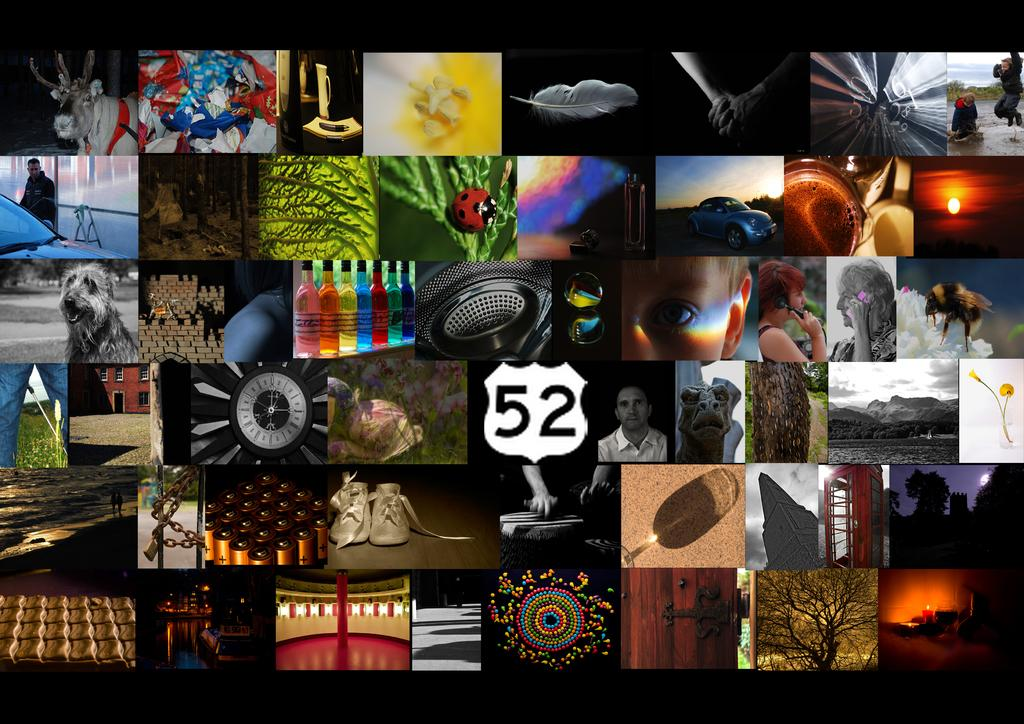<image>
Summarize the visual content of the image. A sign for highway 52 is in a grid of many other images. 